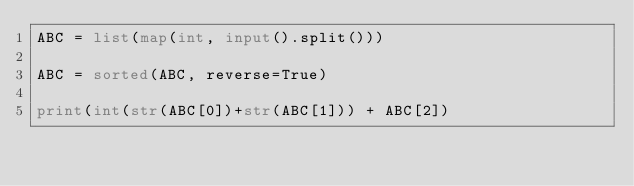<code> <loc_0><loc_0><loc_500><loc_500><_Python_>ABC = list(map(int, input().split()))

ABC = sorted(ABC, reverse=True)

print(int(str(ABC[0])+str(ABC[1])) + ABC[2])




</code> 